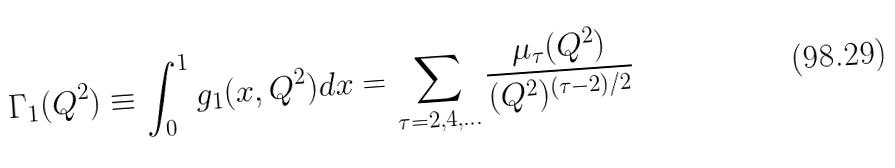Convert formula to latex. <formula><loc_0><loc_0><loc_500><loc_500>\Gamma _ { 1 } ( Q ^ { 2 } ) \equiv \int _ { 0 } ^ { 1 } g _ { 1 } ( x , Q ^ { 2 } ) d x = \sum _ { \tau = 2 , 4 , \dots } \frac { \mu _ { \tau } ( Q ^ { 2 } ) } { ( Q ^ { 2 } ) ^ { ( \tau - 2 ) / 2 } }</formula> 